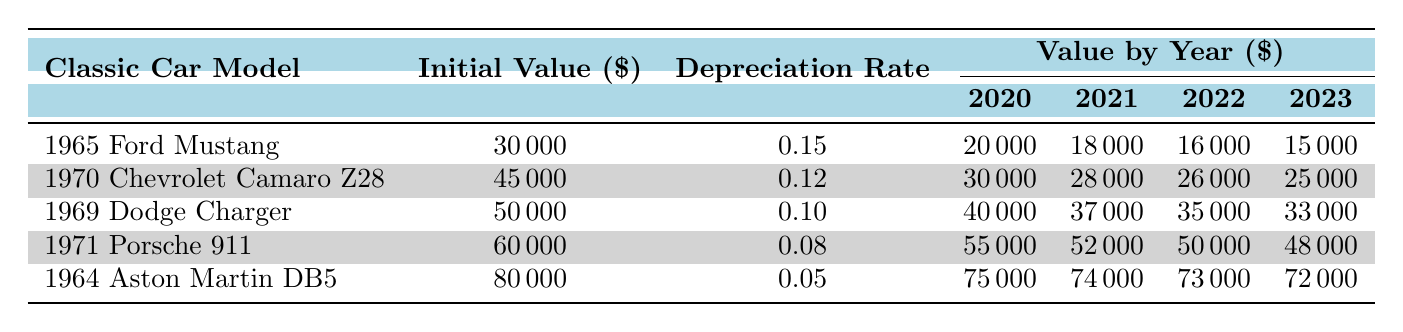What was the initial value of the 1965 Ford Mustang? The initial value of the 1965 Ford Mustang is listed in the table under the "Initial Value" column, which shows a value of $30,000.
Answer: $30,000 Which classic car had the highest value in 2023? Looking at the "Value by Year" for 2023 across the various cars, the 1964 Aston Martin DB5 has the highest value of $72,000 compared to others: $15,000, $25,000, $33,000, and $48,000 for respective models.
Answer: 1964 Aston Martin DB5 What is the average depreciation rate for all classic cars listed in the table? The depreciation rates are 0.15, 0.12, 0.10, 0.08, and 0.05. Adding these gives 0.60, and dividing by 5 (the number of cars) results in an average depreciation rate of 0.12.
Answer: 0.12 Did the value of the 1971 Porsche 911 increase from 2020 to 2023? From the table, the 1971 Porsche 911 had values of $55,000 in 2020 and $48,000 in 2023. Since $48,000 is less than $55,000, the value actually decreased.
Answer: No What was the total depreciation of the 1969 Dodge Charger from 2020 to 2023? The value of the 1969 Dodge Charger decreased from $40,000 in 2020 to $33,000 in 2023. To find the total depreciation, subtract: $40,000 - $33,000 = $7,000.
Answer: $7,000 Which classic car experienced the greatest value drop from 2020 to 2023? To determine this, check the values for each car: Ford Mustang ($20,000 - $15,000 = $5,000), Camaro Z28 ($30,000 - $25,000 = $5,000), Charger ($40,000 - $33,000 = $7,000), Porsche 911 ($55,000 - $48,000 = $7,000), Aston Martin DB5 ($75,000 - $72,000 = $3,000). The Dodge Charger and Porsche 911 both had the largest drops of $7,000.
Answer: 1969 Dodge Charger and 1971 Porsche 911 Is the depreciation rate of the 1964 Aston Martin DB5 lower than that of the 1965 Ford Mustang? The depreciation rate for the Aston Martin DB5 is 0.05, whereas for the Ford Mustang it is 0.15. Since 0.05 is less than 0.15, the statement is true.
Answer: Yes What was the average value of the 1970 Chevrolet Camaro Z28 over the four years? The values for the Camaro Z28 are: $30,000, $28,000, $26,000, and $25,000. Adding these yields 109,000. Dividing by 4 gives an average of $27,250.
Answer: $27,250 